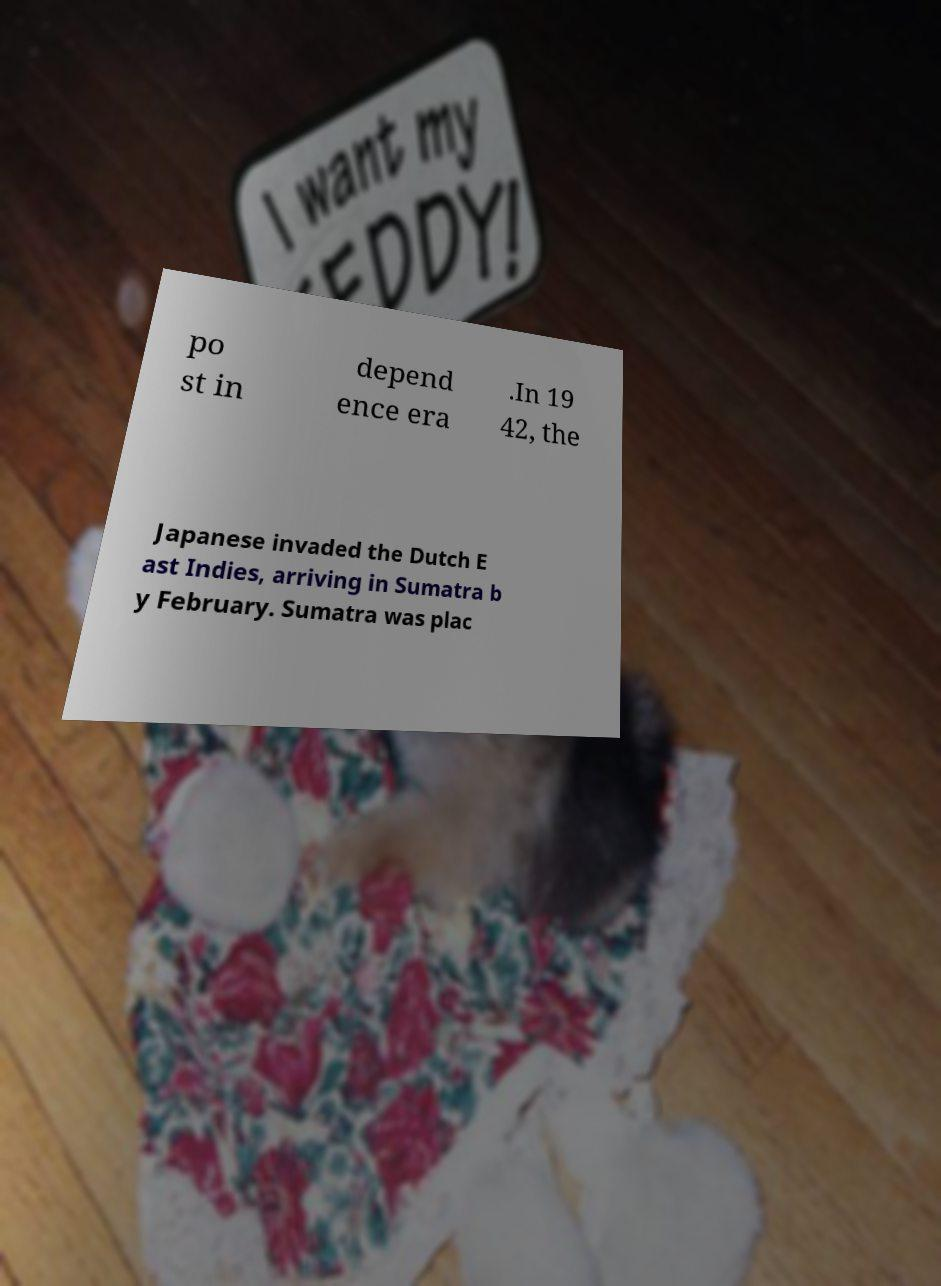For documentation purposes, I need the text within this image transcribed. Could you provide that? po st in depend ence era .In 19 42, the Japanese invaded the Dutch E ast Indies, arriving in Sumatra b y February. Sumatra was plac 